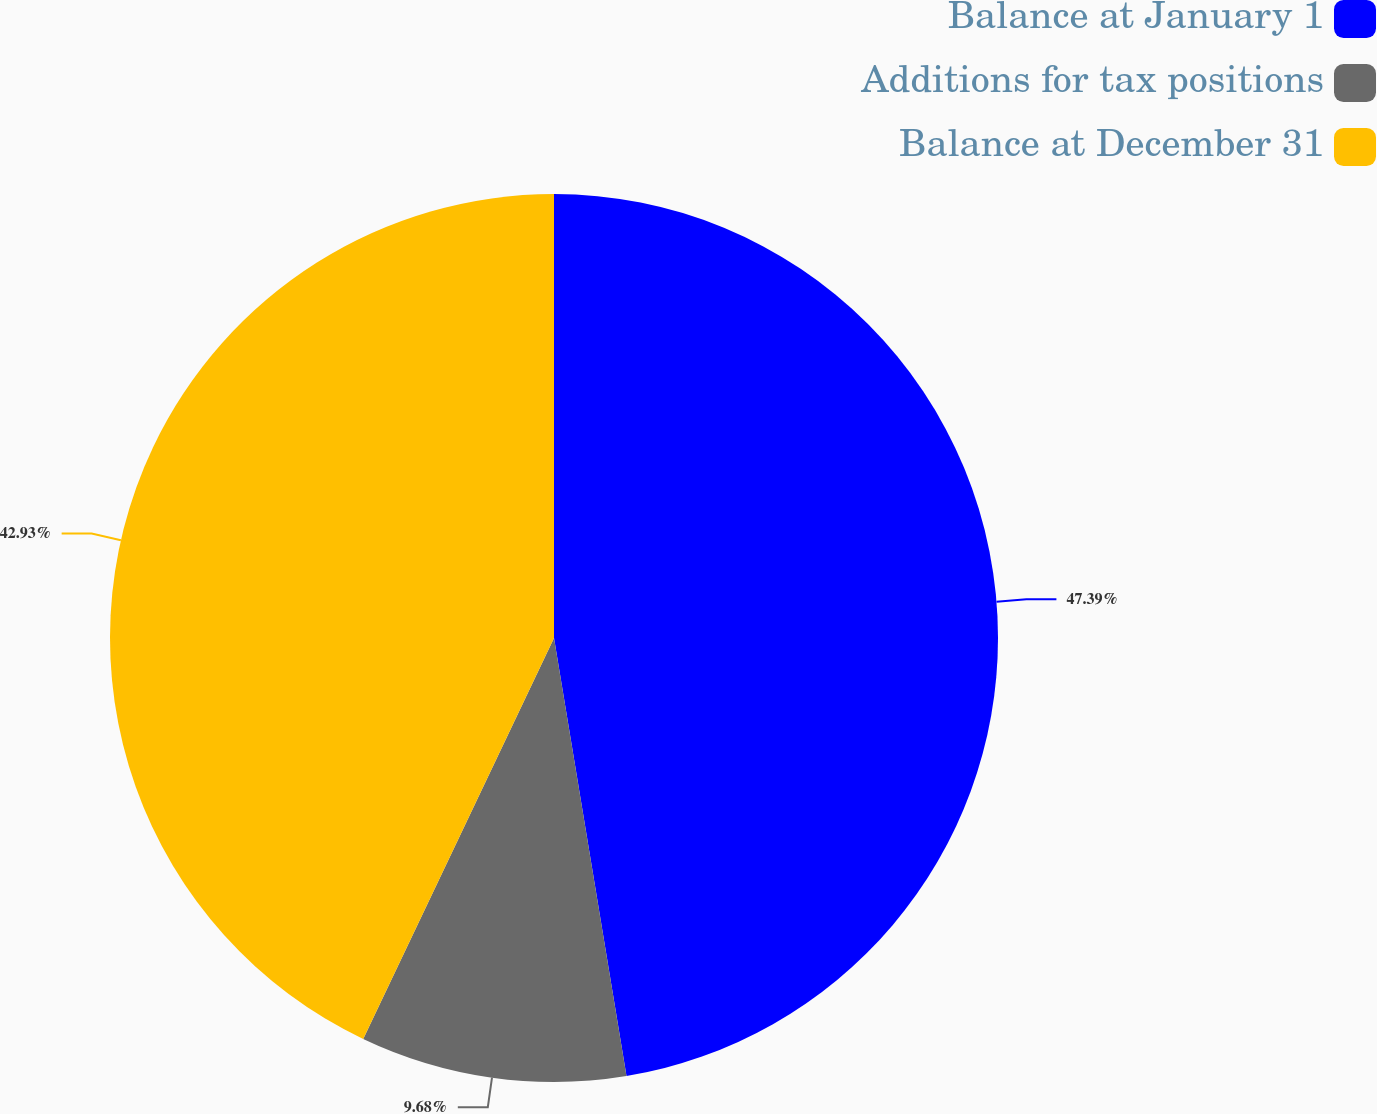Convert chart to OTSL. <chart><loc_0><loc_0><loc_500><loc_500><pie_chart><fcel>Balance at January 1<fcel>Additions for tax positions<fcel>Balance at December 31<nl><fcel>47.39%<fcel>9.68%<fcel>42.93%<nl></chart> 